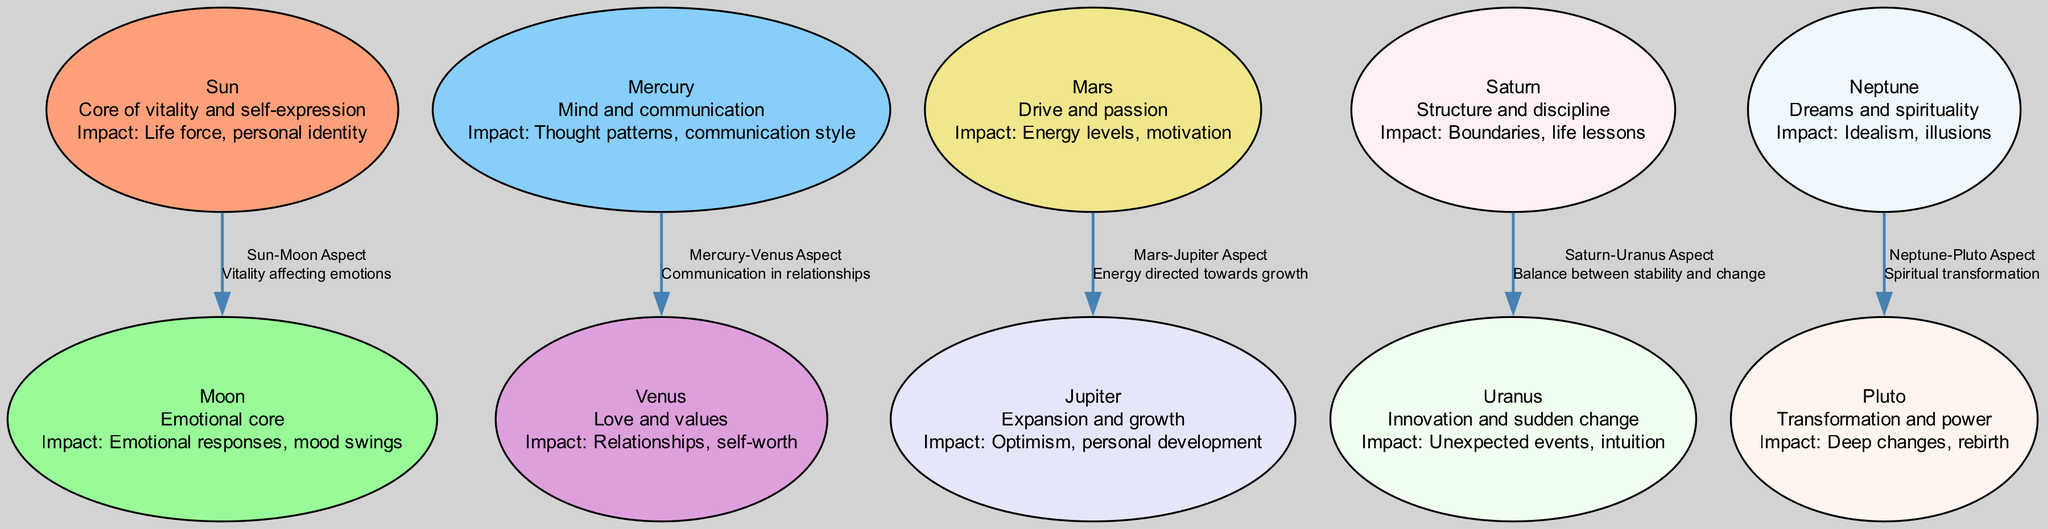What is the total number of nodes in the diagram? There are ten distinct nodes listed in the data under the "nodes" section. Each planet and the Sun and Moon are represented as a node, totaling ten.
Answer: 10 What does the "Mars" node represent? The "Mars" node contains the label "Mars," with a description indicating that it represents drive and passion, along with its impact on energy levels and motivation.
Answer: Drive and passion What is the relationship between the "Sun" and "Moon"? The edge connecting the "Sun" and "Moon" nodes states that the relationship is the "Sun-Moon Aspect" and indicates that the influence is that vitality affects emotions.
Answer: Sun-Moon Aspect Which node is related to "spirituality"? Referring to the data, the "Neptune" node is described as relating to dreams and spirituality.
Answer: Neptune What is the impact of "Saturn" on emotional well-being? The "Saturn" node states that its impact is about structure and discipline, which includes boundaries and life lessons. This indicates a stabilizing influence on emotional well-being.
Answer: Boundaries, life lessons How does the "Mercury-Venus Aspect" influence relationships? The "Mercury-Venus Aspect" is specified as impacting communication in relationships, linking the communication skills of Mercury with the values of Venus, which affects how people express love and connect.
Answer: Communication in relationships What is the connection between "Neptune" and "Pluto"? The diagram indicates that the "Neptune-Pluto Aspect" exists, meaning there is a correlation between Neptune's influence on dreams and spirituality and Pluto's influence on transformation and power, denoting spiritual transformation.
Answer: Spiritual transformation Which planet is associated with personal development? The "Jupiter" node in the diagram highlights its association with expansion and growth, making it connected to personal development and optimism.
Answer: Jupiter What is the influence of "Mars" on "Jupiter"? The edge indicates a "Mars-Jupiter Aspect," noting that the influence is energy directed towards growth, showing how Mars's drive can enhance Jupiter's expansive qualities.
Answer: Energy directed towards growth 